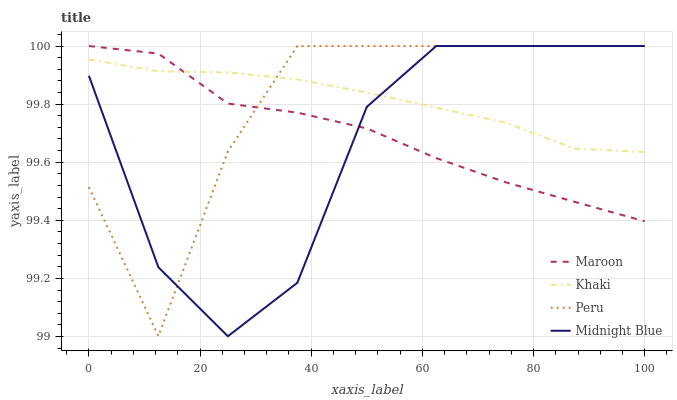Does Midnight Blue have the minimum area under the curve?
Answer yes or no. Yes. Does Khaki have the maximum area under the curve?
Answer yes or no. Yes. Does Peru have the minimum area under the curve?
Answer yes or no. No. Does Peru have the maximum area under the curve?
Answer yes or no. No. Is Khaki the smoothest?
Answer yes or no. Yes. Is Midnight Blue the roughest?
Answer yes or no. Yes. Is Peru the smoothest?
Answer yes or no. No. Is Peru the roughest?
Answer yes or no. No. Does Midnight Blue have the lowest value?
Answer yes or no. Yes. Does Peru have the lowest value?
Answer yes or no. No. Does Midnight Blue have the highest value?
Answer yes or no. Yes. Does Midnight Blue intersect Maroon?
Answer yes or no. Yes. Is Midnight Blue less than Maroon?
Answer yes or no. No. Is Midnight Blue greater than Maroon?
Answer yes or no. No. 